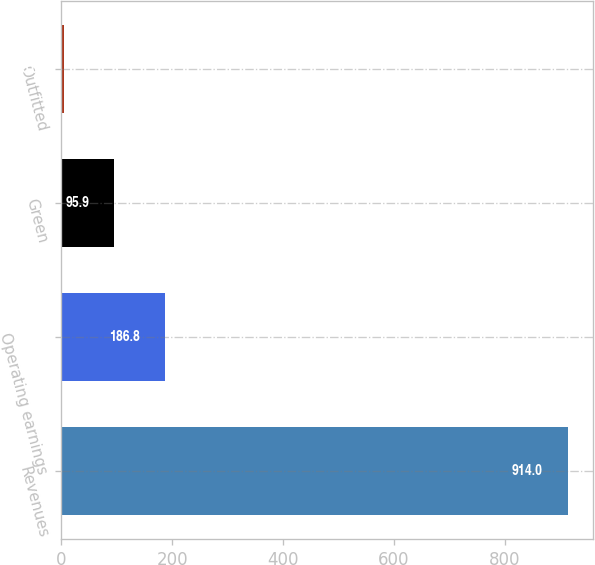Convert chart to OTSL. <chart><loc_0><loc_0><loc_500><loc_500><bar_chart><fcel>Revenues<fcel>Operating earnings<fcel>Green<fcel>Outfitted<nl><fcel>914<fcel>186.8<fcel>95.9<fcel>5<nl></chart> 